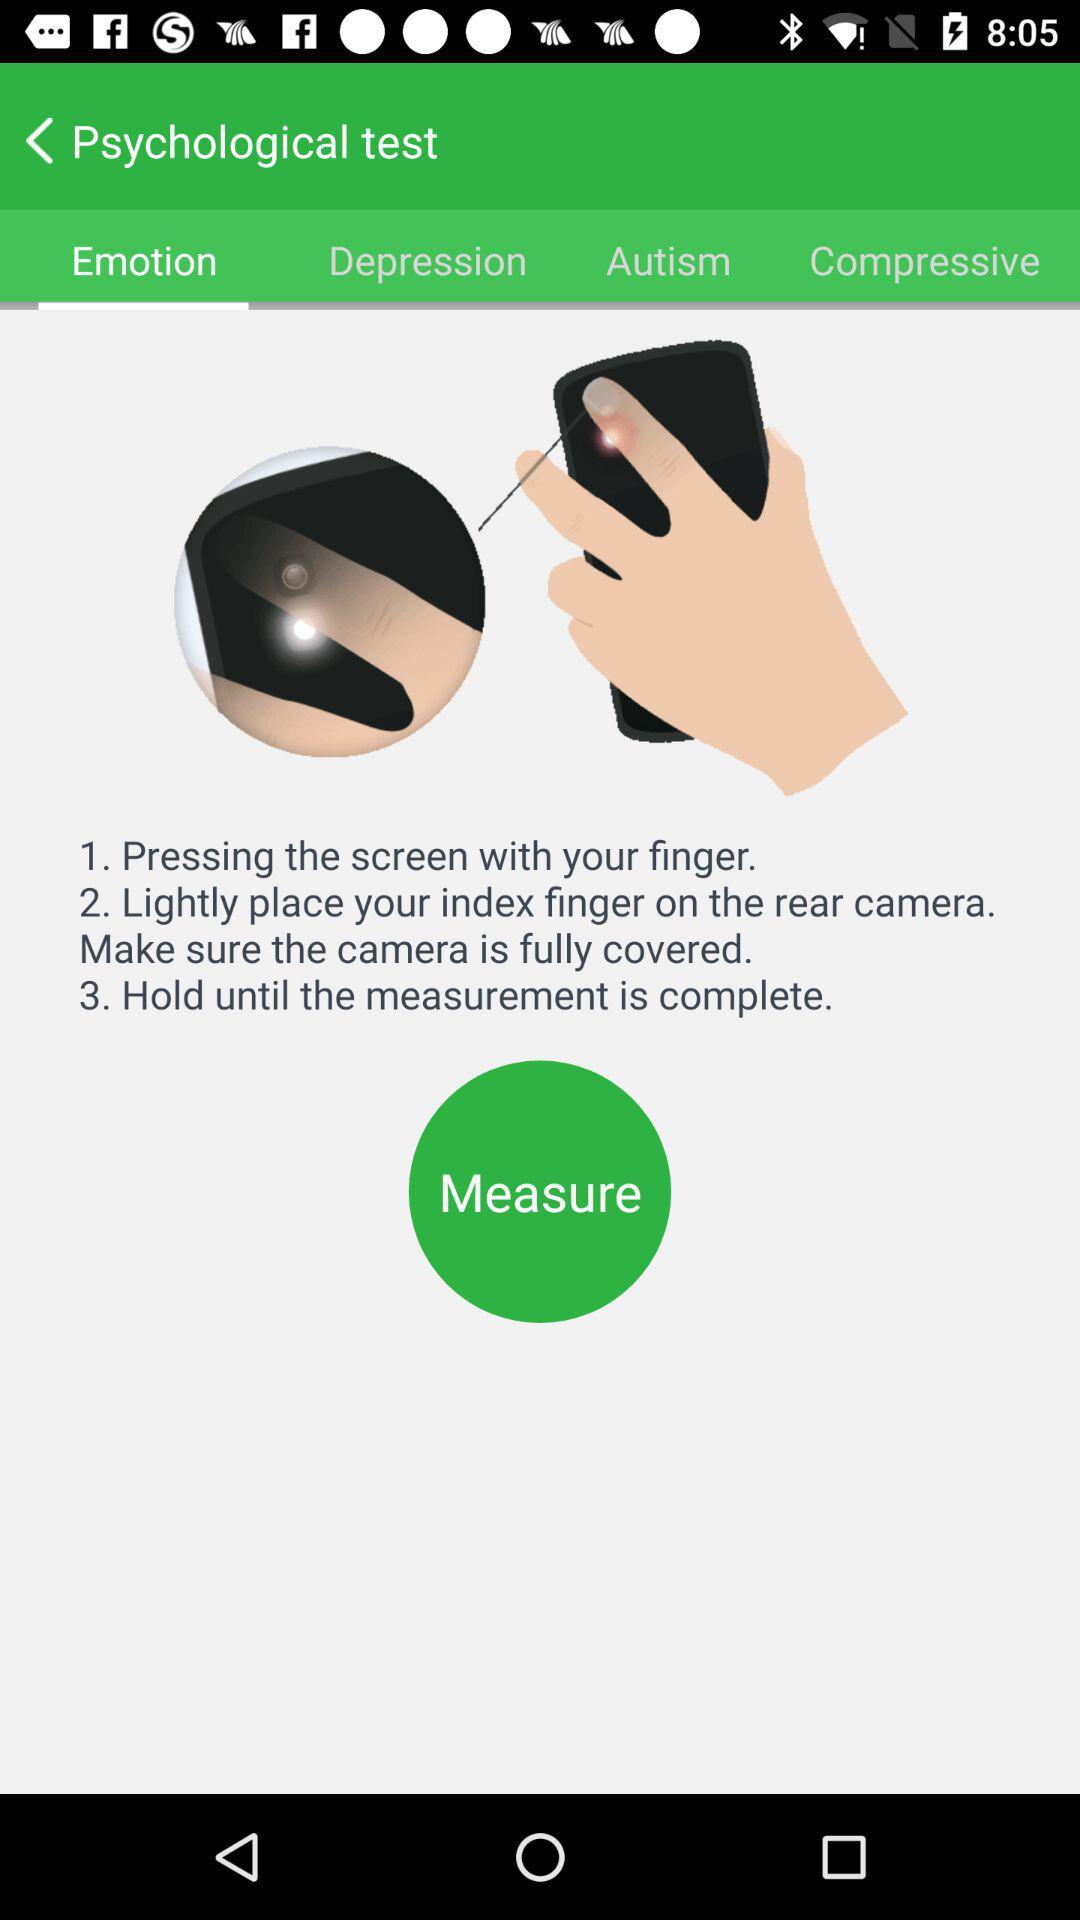How many seconds does it take to complete the measurement?
When the provided information is insufficient, respond with <no answer>. <no answer> 